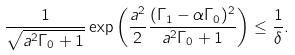Convert formula to latex. <formula><loc_0><loc_0><loc_500><loc_500>\frac { 1 } { \sqrt { a ^ { 2 } \Gamma _ { 0 } + 1 } } \exp \left ( \frac { a ^ { 2 } } { 2 } \frac { ( \Gamma _ { 1 } - \alpha \Gamma _ { 0 } ) ^ { 2 } } { a ^ { 2 } \Gamma _ { 0 } + 1 } \right ) \leq \frac { 1 } { \delta } .</formula> 